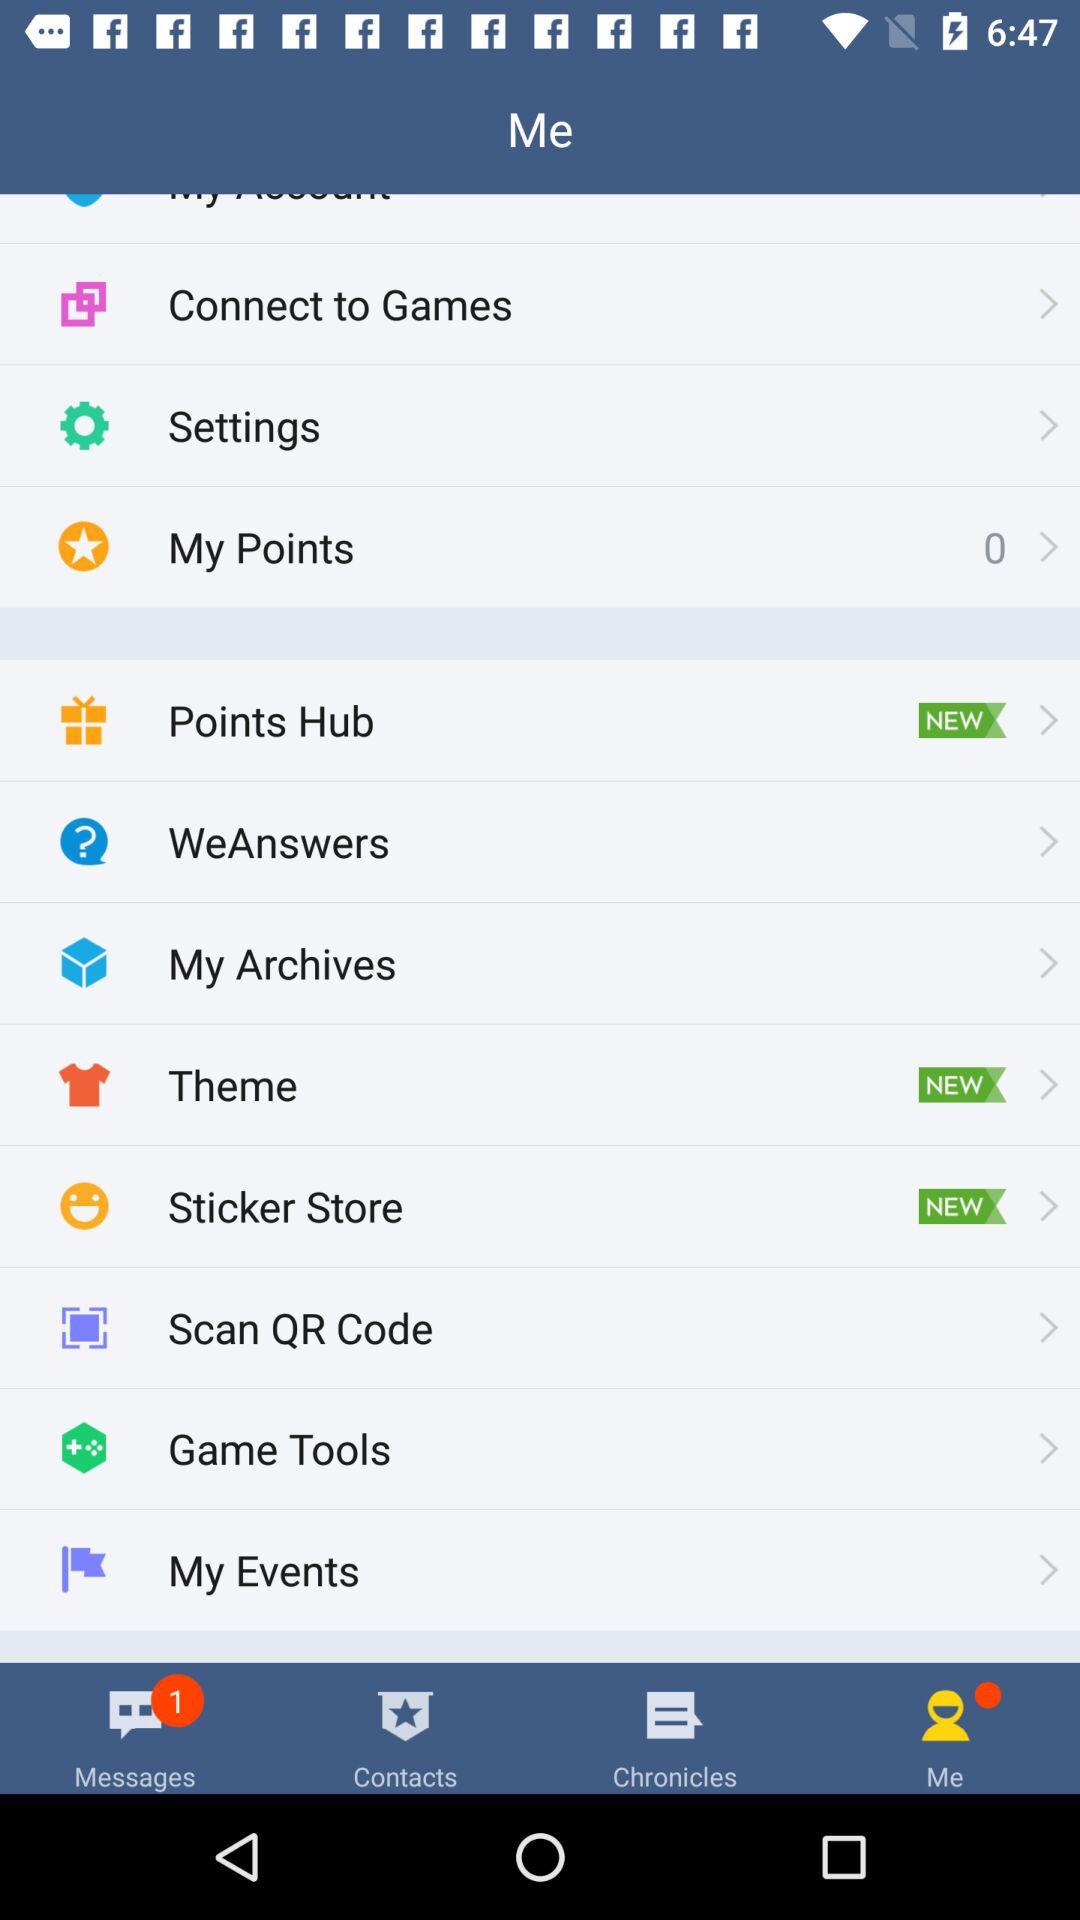Which tab is selected? The selected tab is "Me". 